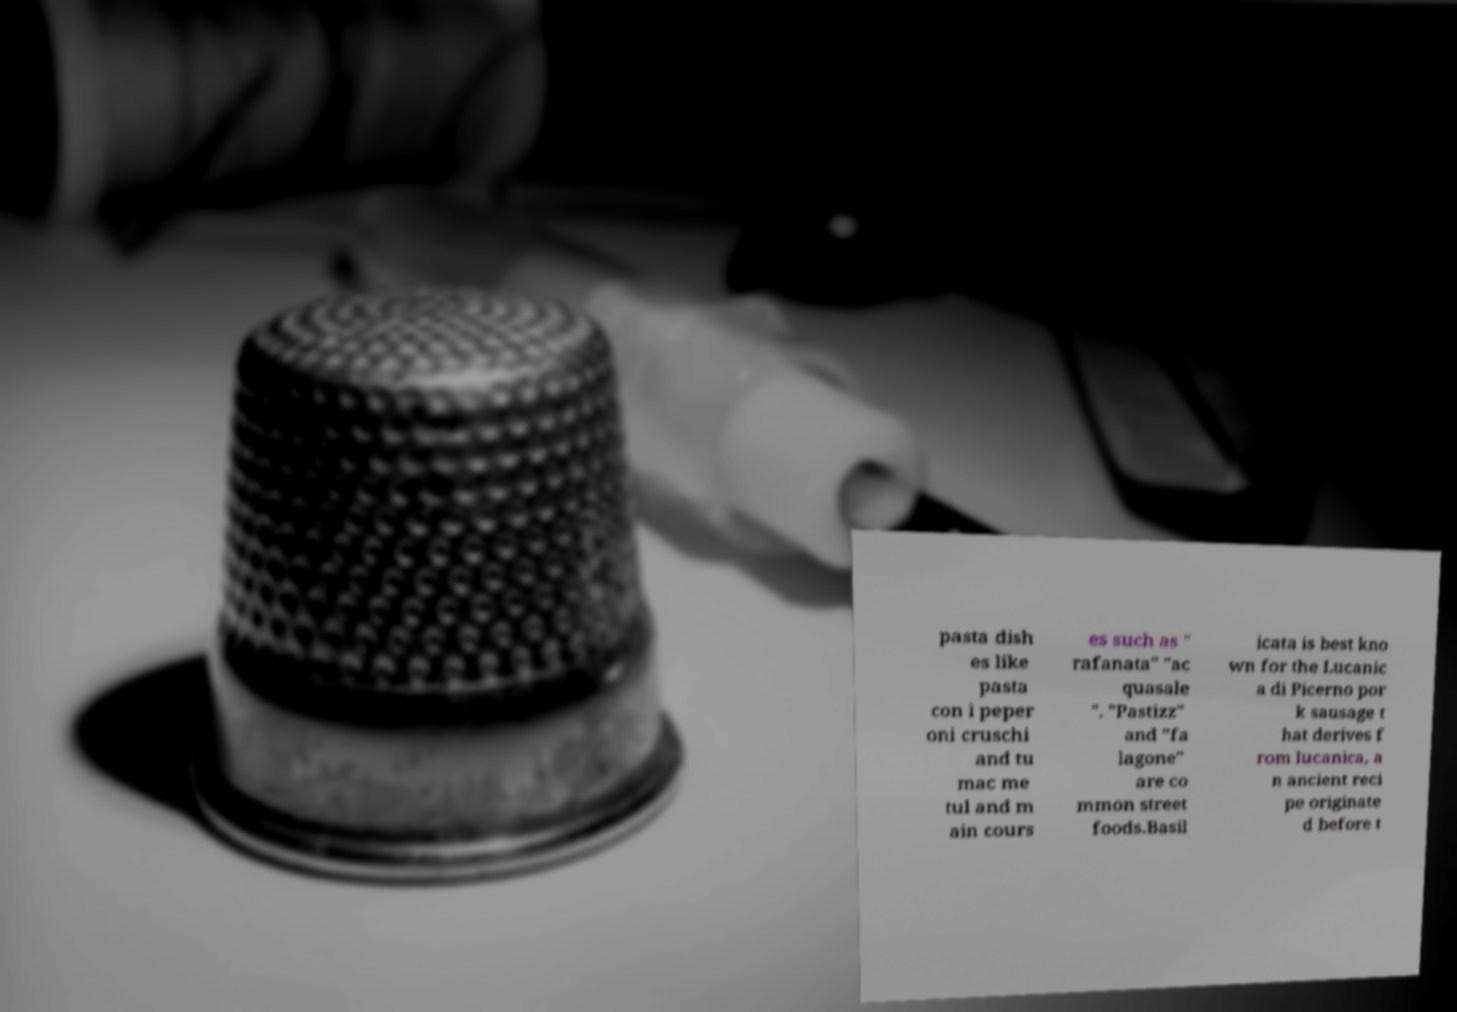Could you assist in decoding the text presented in this image and type it out clearly? pasta dish es like pasta con i peper oni cruschi and tu mac me tul and m ain cours es such as " rafanata" "ac quasale ". "Pastizz" and "fa lagone" are co mmon street foods.Basil icata is best kno wn for the Lucanic a di Picerno por k sausage t hat derives f rom lucanica, a n ancient reci pe originate d before t 